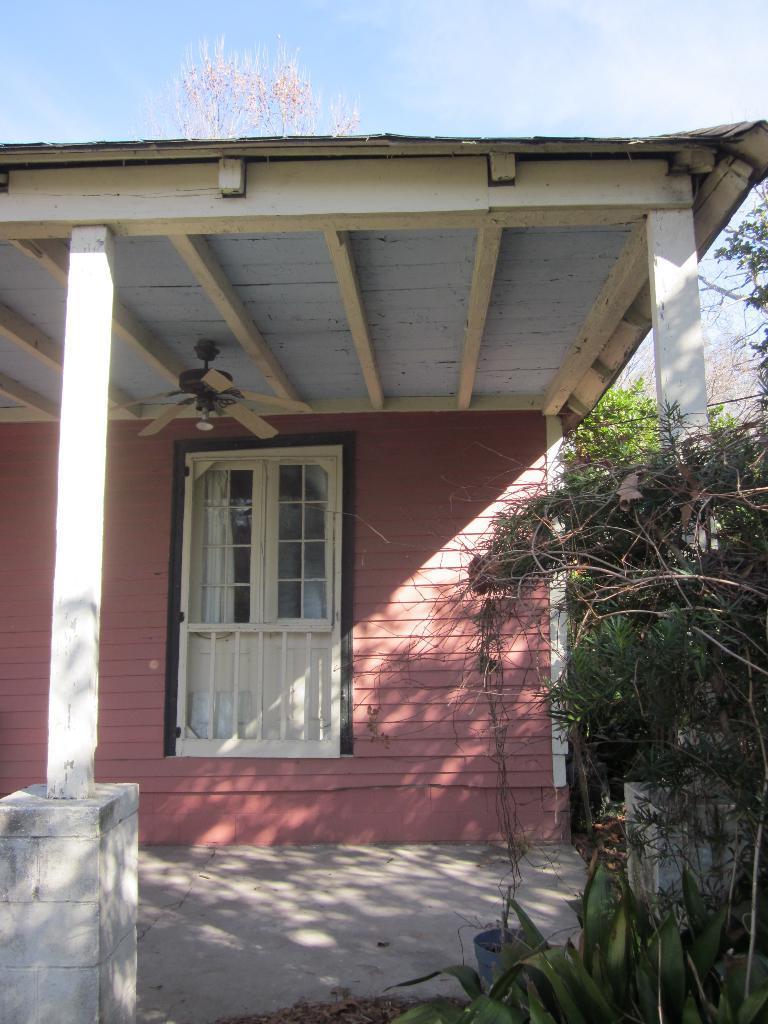Could you give a brief overview of what you see in this image? In this image there is a house to that house there is a window, at the top there is a fan, on the right side there are trees in the background there is the sky. 